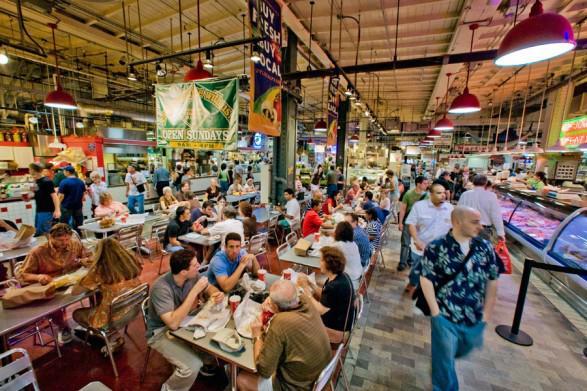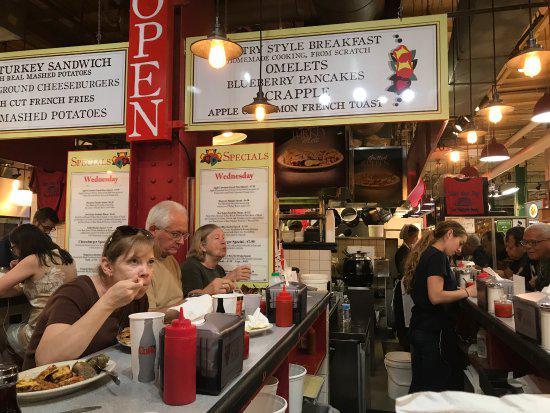The first image is the image on the left, the second image is the image on the right. For the images shown, is this caption "More than six people are sitting on bar stools." true? Answer yes or no. No. The first image is the image on the left, the second image is the image on the right. Considering the images on both sides, is "In at least one image the is a menu framed in red sitting on a black countertop." valid? Answer yes or no. No. 